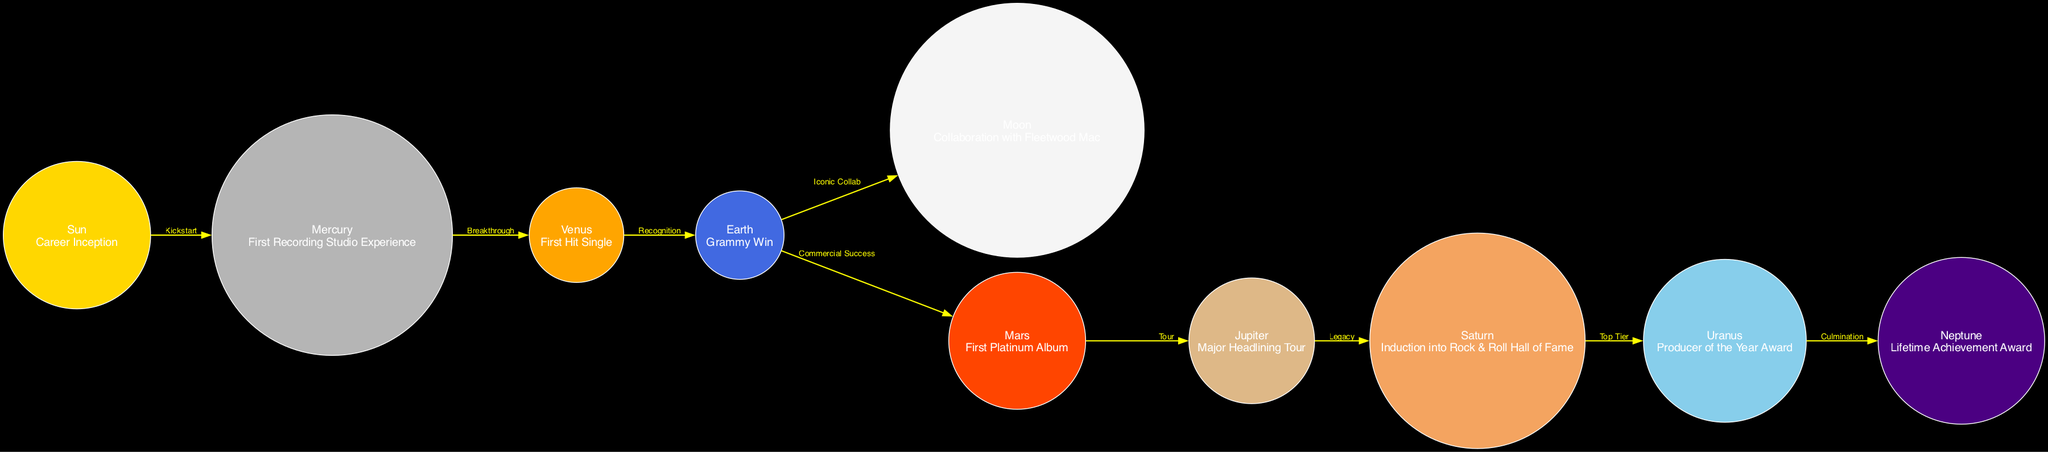What does the "Sun" represent in the diagram? The "Sun" in the diagram represents the initial stage of the producer's career, labeled as "Career Inception." This is confirmed by the node's description.
Answer: Career Inception How many nodes are present in the diagram? To find the number of nodes, we count each unique celestial body listed in the nodes section. There are 10 distinct nodes (Sun, Mercury, Venus, Earth, Moon, Mars, Jupiter, Saturn, Uranus, Neptune).
Answer: 10 What does the edge between "Earth" and "Moon" signify? The edge between "Earth" and "Moon" is labeled "Iconic Collab," indicating a significant collaboration in the producer's career occurring after the Grammy win represented by "Earth." This relationship shows a pivotal moment in the career timeline.
Answer: Iconic Collab Which milestone comes after the "First Hit Single"? The node for "First Hit Single" is represented by Venus, and from the edges, we see that the next milestone connected is "Grammy Win," represented by Earth, indicating career recognition after achieving the hit.
Answer: Grammy Win What is the significance of the edge labeled "Legacy"? The edge labeled "Legacy" connects "Jupiter" to "Saturn." This suggests that after completing a major headlining tour (Jupiter), the producer's work contributed to a lasting impact on the industry, leading to induction into the Rock & Roll Hall of Fame (Saturn).
Answer: Legacy What is the final milestone represented in the diagram? The final node connected in a continuous flow is "Neptune," which stands for "Lifetime Achievement Award." This signifies the culmination of the producer's career accomplishments represented in the diagram.
Answer: Lifetime Achievement Award How many edges connect to "Mars"? "Mars" is connected by one edge, leading to "Jupiter." Thus, after achieving the first platinum album represented by Mars, the producer progresses to major headlining tours connected to Jupiter.
Answer: 1 What does the label "Top Tier" indicate in relation to "Uranus"? The label "Top Tier" connects the node "Saturn" to "Uranus," illustrating that being inducted into the Rock & Roll Hall of Fame (Saturn) elevates the producer to a high level of recognition within the music industry categorized as prestigious or elite.
Answer: Top Tier What relationship exists between "Neptune" and "Uranus"? The relationship indicated by the edge from "Uranus" to "Neptune" is labeled "Culmination." This signifies that the accolades achieved as 'Producer of the Year' lead to the highest recognition in the industry, marked by the "Lifetime Achievement Award" at the end of the career timeline.
Answer: Culmination 